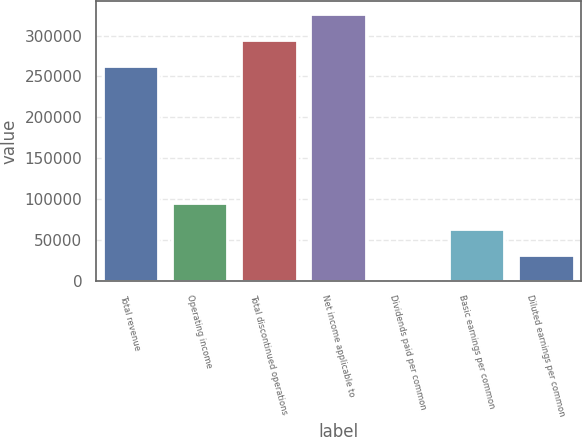<chart> <loc_0><loc_0><loc_500><loc_500><bar_chart><fcel>Total revenue<fcel>Operating income<fcel>Total discontinued operations<fcel>Net income applicable to<fcel>Dividends paid per common<fcel>Basic earnings per common<fcel>Diluted earnings per common<nl><fcel>262463<fcel>95060.1<fcel>294150<fcel>325836<fcel>0.45<fcel>63373.6<fcel>31687<nl></chart> 